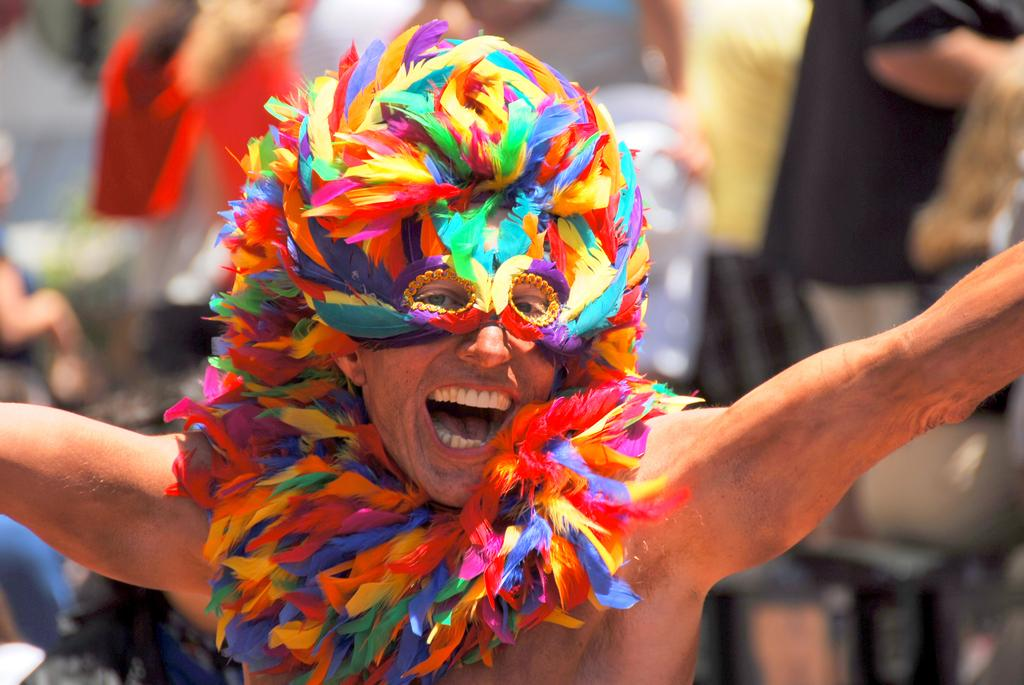What is the main subject of the image? There is a person standing in the image. What is the person in the image doing? The person is laughing. Can you describe the appearance of the other person in the image? The other person is wearing bird's feathers in multiple colors. What type of sugar can be seen in the image? There is no sugar present in the image. How many zebras are visible in the image? There are no zebras visible in the image. 